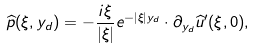<formula> <loc_0><loc_0><loc_500><loc_500>\widehat { p } ( \xi , y _ { d } ) = - \frac { i \xi } { | \xi | } e ^ { - | \xi | y _ { d } } \cdot \partial _ { y _ { d } } \widehat { u } ^ { \prime } ( \xi , 0 ) ,</formula> 